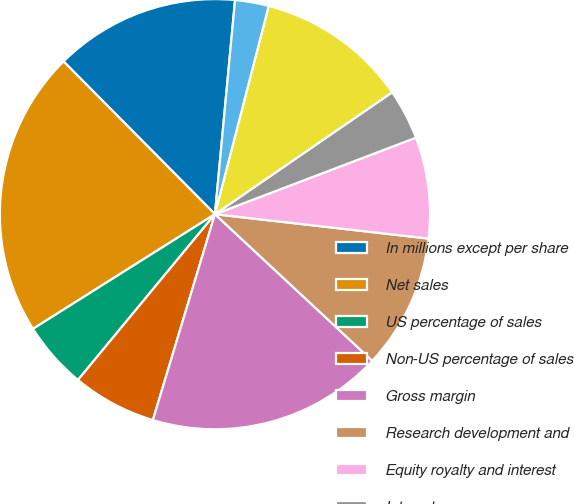<chart> <loc_0><loc_0><loc_500><loc_500><pie_chart><fcel>In millions except per share<fcel>Net sales<fcel>US percentage of sales<fcel>Non-US percentage of sales<fcel>Gross margin<fcel>Research development and<fcel>Equity royalty and interest<fcel>Interest expense<fcel>Net income attributable to<fcel>Basic<nl><fcel>13.92%<fcel>21.52%<fcel>5.06%<fcel>6.33%<fcel>17.72%<fcel>10.13%<fcel>7.6%<fcel>3.8%<fcel>11.39%<fcel>2.53%<nl></chart> 